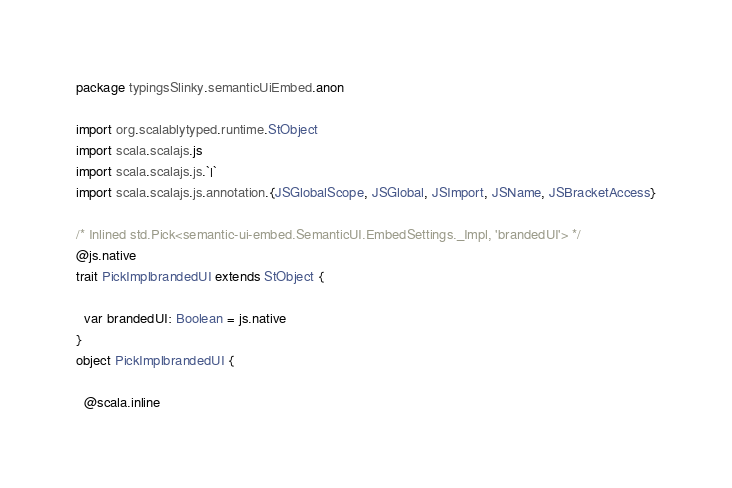<code> <loc_0><loc_0><loc_500><loc_500><_Scala_>package typingsSlinky.semanticUiEmbed.anon

import org.scalablytyped.runtime.StObject
import scala.scalajs.js
import scala.scalajs.js.`|`
import scala.scalajs.js.annotation.{JSGlobalScope, JSGlobal, JSImport, JSName, JSBracketAccess}

/* Inlined std.Pick<semantic-ui-embed.SemanticUI.EmbedSettings._Impl, 'brandedUI'> */
@js.native
trait PickImplbrandedUI extends StObject {
  
  var brandedUI: Boolean = js.native
}
object PickImplbrandedUI {
  
  @scala.inline</code> 